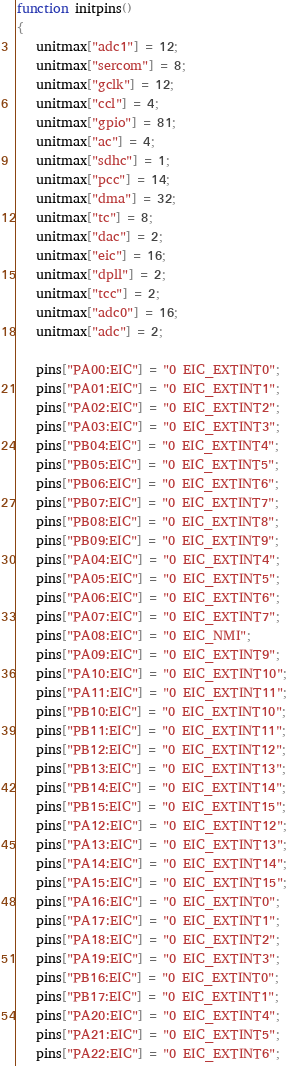Convert code to text. <code><loc_0><loc_0><loc_500><loc_500><_Awk_>function initpins()
{
   unitmax["adc1"] = 12;
   unitmax["sercom"] = 8;
   unitmax["gclk"] = 12;
   unitmax["ccl"] = 4;
   unitmax["gpio"] = 81;
   unitmax["ac"] = 4;
   unitmax["sdhc"] = 1;
   unitmax["pcc"] = 14;
   unitmax["dma"] = 32;
   unitmax["tc"] = 8;
   unitmax["dac"] = 2;
   unitmax["eic"] = 16;
   unitmax["dpll"] = 2;
   unitmax["tcc"] = 2;
   unitmax["adc0"] = 16;
   unitmax["adc"] = 2;

   pins["PA00:EIC"] = "0 EIC_EXTINT0";
   pins["PA01:EIC"] = "0 EIC_EXTINT1";
   pins["PA02:EIC"] = "0 EIC_EXTINT2";
   pins["PA03:EIC"] = "0 EIC_EXTINT3";
   pins["PB04:EIC"] = "0 EIC_EXTINT4";
   pins["PB05:EIC"] = "0 EIC_EXTINT5";
   pins["PB06:EIC"] = "0 EIC_EXTINT6";
   pins["PB07:EIC"] = "0 EIC_EXTINT7";
   pins["PB08:EIC"] = "0 EIC_EXTINT8";
   pins["PB09:EIC"] = "0 EIC_EXTINT9";
   pins["PA04:EIC"] = "0 EIC_EXTINT4";
   pins["PA05:EIC"] = "0 EIC_EXTINT5";
   pins["PA06:EIC"] = "0 EIC_EXTINT6";
   pins["PA07:EIC"] = "0 EIC_EXTINT7";
   pins["PA08:EIC"] = "0 EIC_NMI";
   pins["PA09:EIC"] = "0 EIC_EXTINT9";
   pins["PA10:EIC"] = "0 EIC_EXTINT10";
   pins["PA11:EIC"] = "0 EIC_EXTINT11";
   pins["PB10:EIC"] = "0 EIC_EXTINT10";
   pins["PB11:EIC"] = "0 EIC_EXTINT11";
   pins["PB12:EIC"] = "0 EIC_EXTINT12";
   pins["PB13:EIC"] = "0 EIC_EXTINT13";
   pins["PB14:EIC"] = "0 EIC_EXTINT14";
   pins["PB15:EIC"] = "0 EIC_EXTINT15";
   pins["PA12:EIC"] = "0 EIC_EXTINT12";
   pins["PA13:EIC"] = "0 EIC_EXTINT13";
   pins["PA14:EIC"] = "0 EIC_EXTINT14";
   pins["PA15:EIC"] = "0 EIC_EXTINT15";
   pins["PA16:EIC"] = "0 EIC_EXTINT0";
   pins["PA17:EIC"] = "0 EIC_EXTINT1";
   pins["PA18:EIC"] = "0 EIC_EXTINT2";
   pins["PA19:EIC"] = "0 EIC_EXTINT3";
   pins["PB16:EIC"] = "0 EIC_EXTINT0";
   pins["PB17:EIC"] = "0 EIC_EXTINT1";
   pins["PA20:EIC"] = "0 EIC_EXTINT4";
   pins["PA21:EIC"] = "0 EIC_EXTINT5";
   pins["PA22:EIC"] = "0 EIC_EXTINT6";</code> 